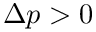<formula> <loc_0><loc_0><loc_500><loc_500>\Delta p > 0</formula> 